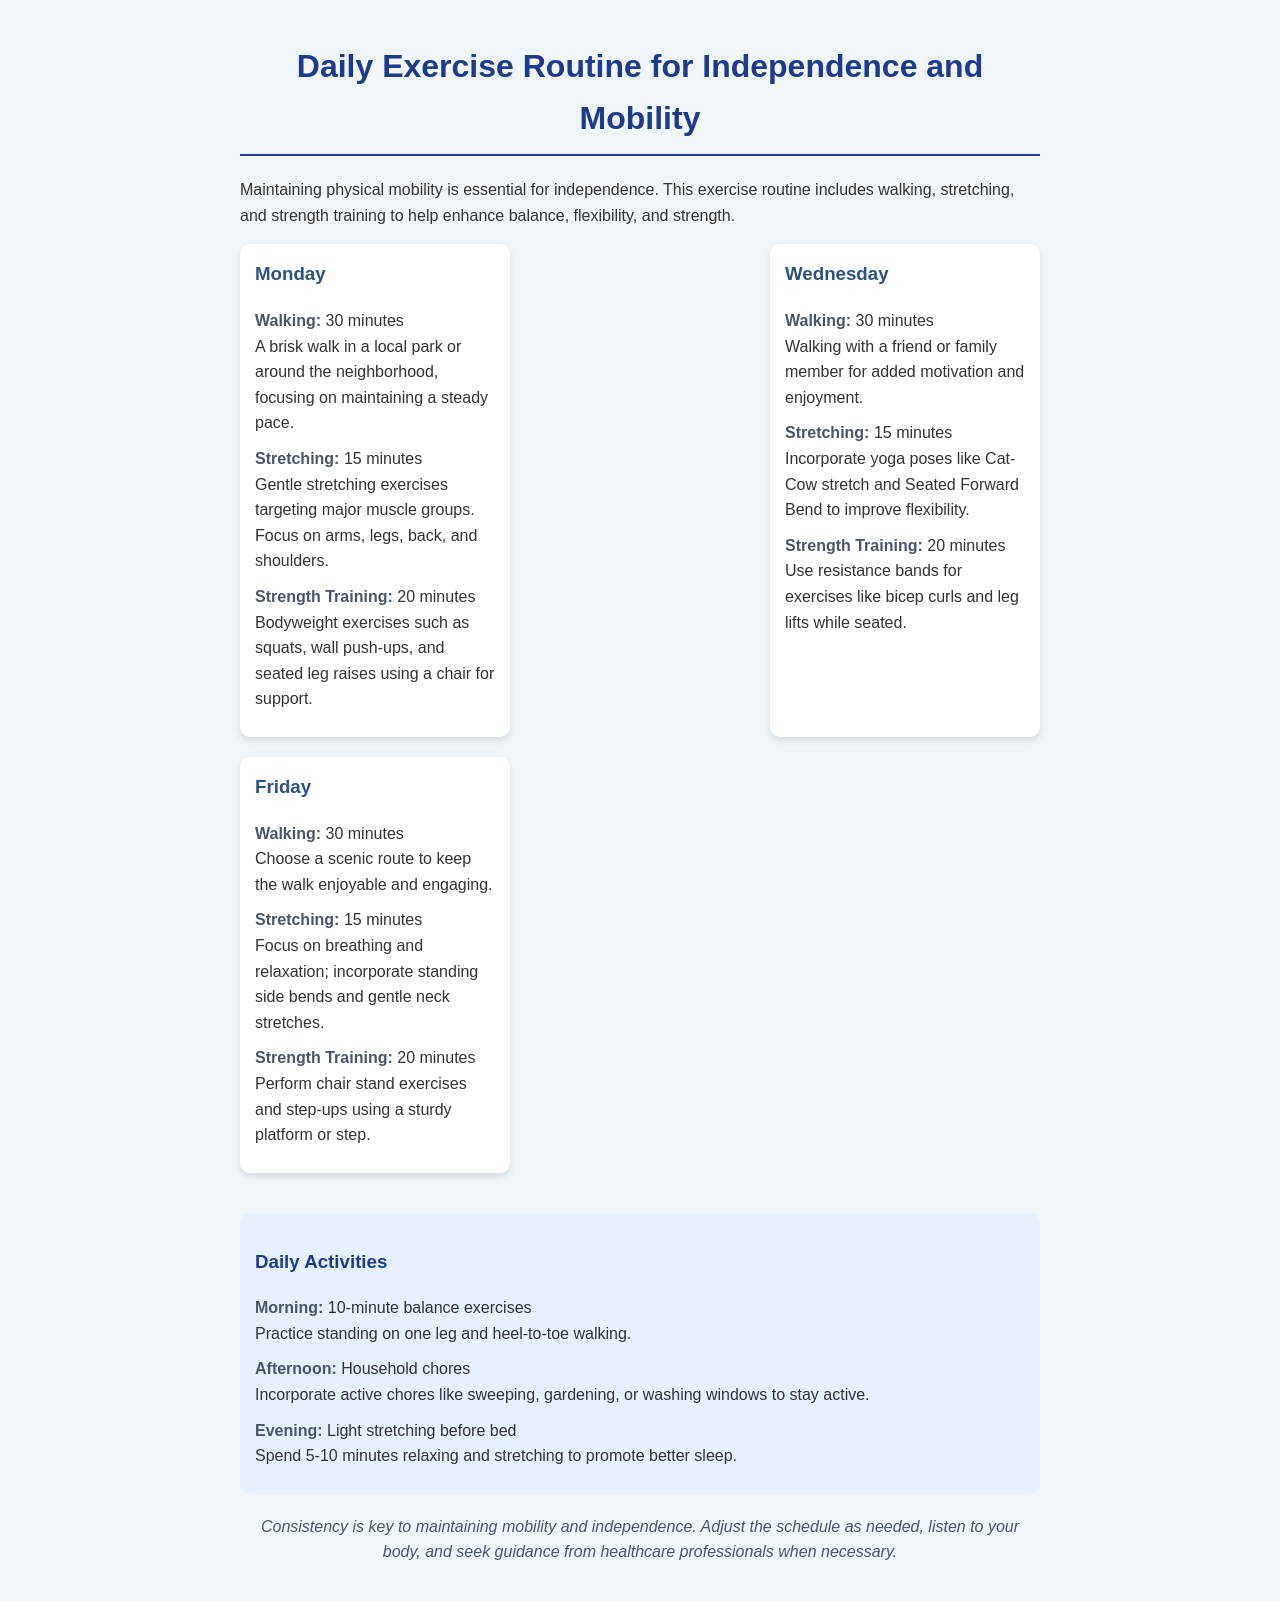What activities are scheduled for Monday? The document lists walking, stretching, and strength training for Monday.
Answer: walking, stretching, strength training How long is the walking session on Wednesday? The walking session on Wednesday is scheduled for 30 minutes.
Answer: 30 minutes What type of strength training exercise is mentioned for Friday? On Friday, chair stand exercises and step-ups are mentioned as strength training exercises.
Answer: chair stand exercises and step-ups What is recommended for the afternoon daily activity? The afternoon daily activity suggests incorporating active chores like sweeping, gardening, or washing windows.
Answer: Household chores How many minutes are allocated for stretching on any exercise day? Each exercise day allocates 15 minutes for stretching.
Answer: 15 minutes What is the total time spent on strength training across the scheduled days? The strength training time totals 20 minutes for each of the three exercise days, which sums to 60 minutes.
Answer: 60 minutes What does the conclusion emphasize about maintaining mobility? The conclusion emphasizes that consistency is key to maintaining mobility and independence.
Answer: Consistency What is the focus of the morning daily activity? The focus of the morning daily activity is on balance exercises.
Answer: balance exercises 